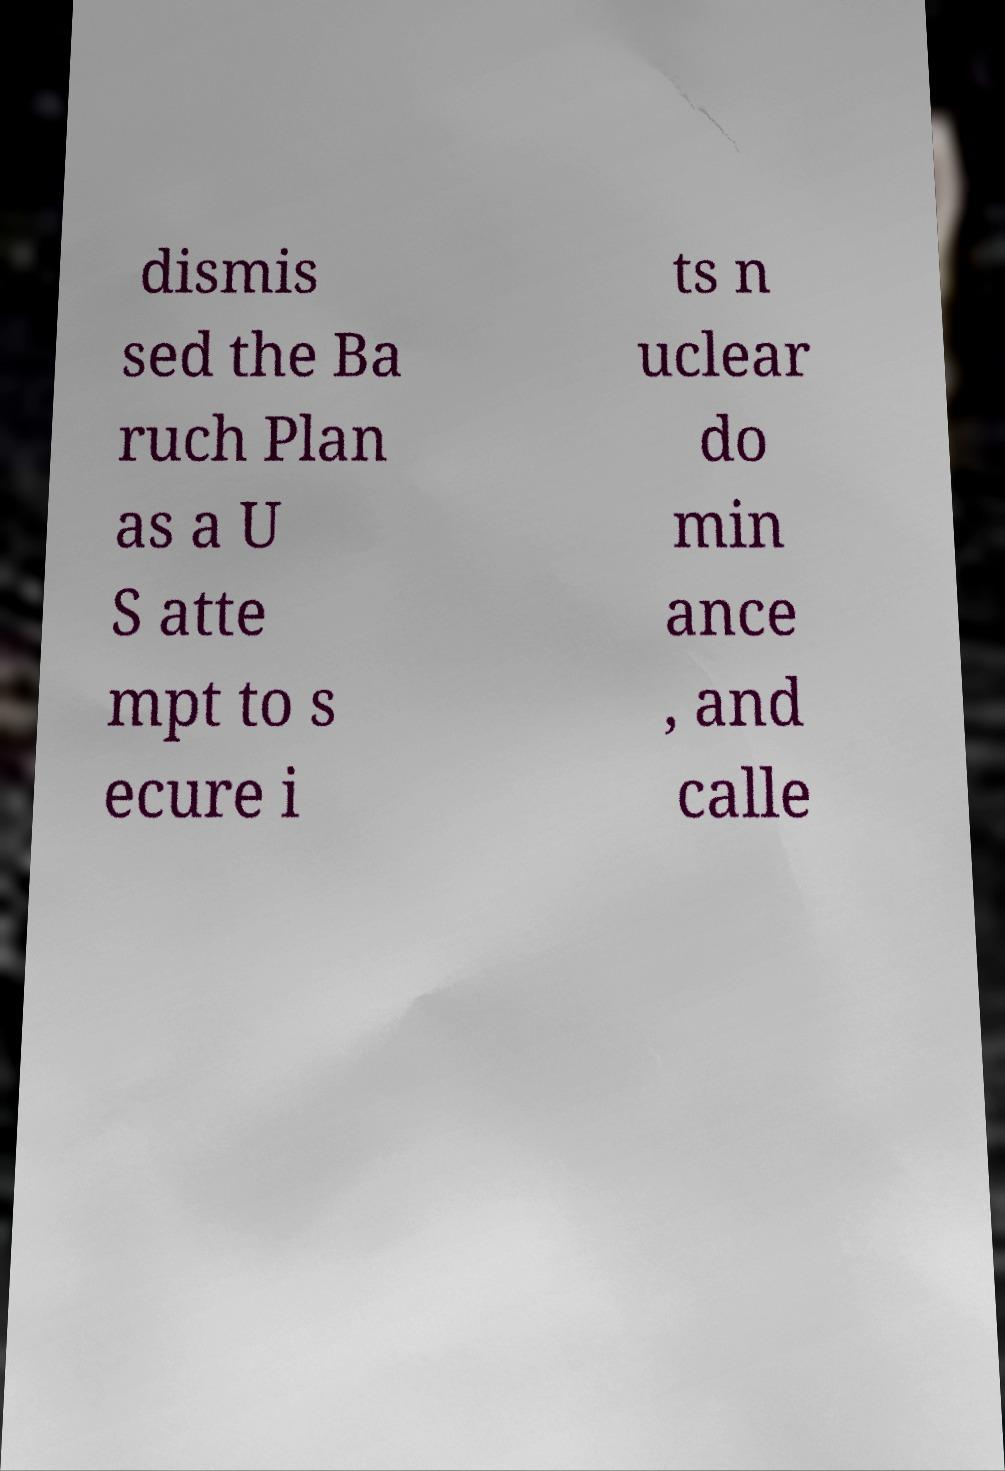Could you assist in decoding the text presented in this image and type it out clearly? dismis sed the Ba ruch Plan as a U S atte mpt to s ecure i ts n uclear do min ance , and calle 